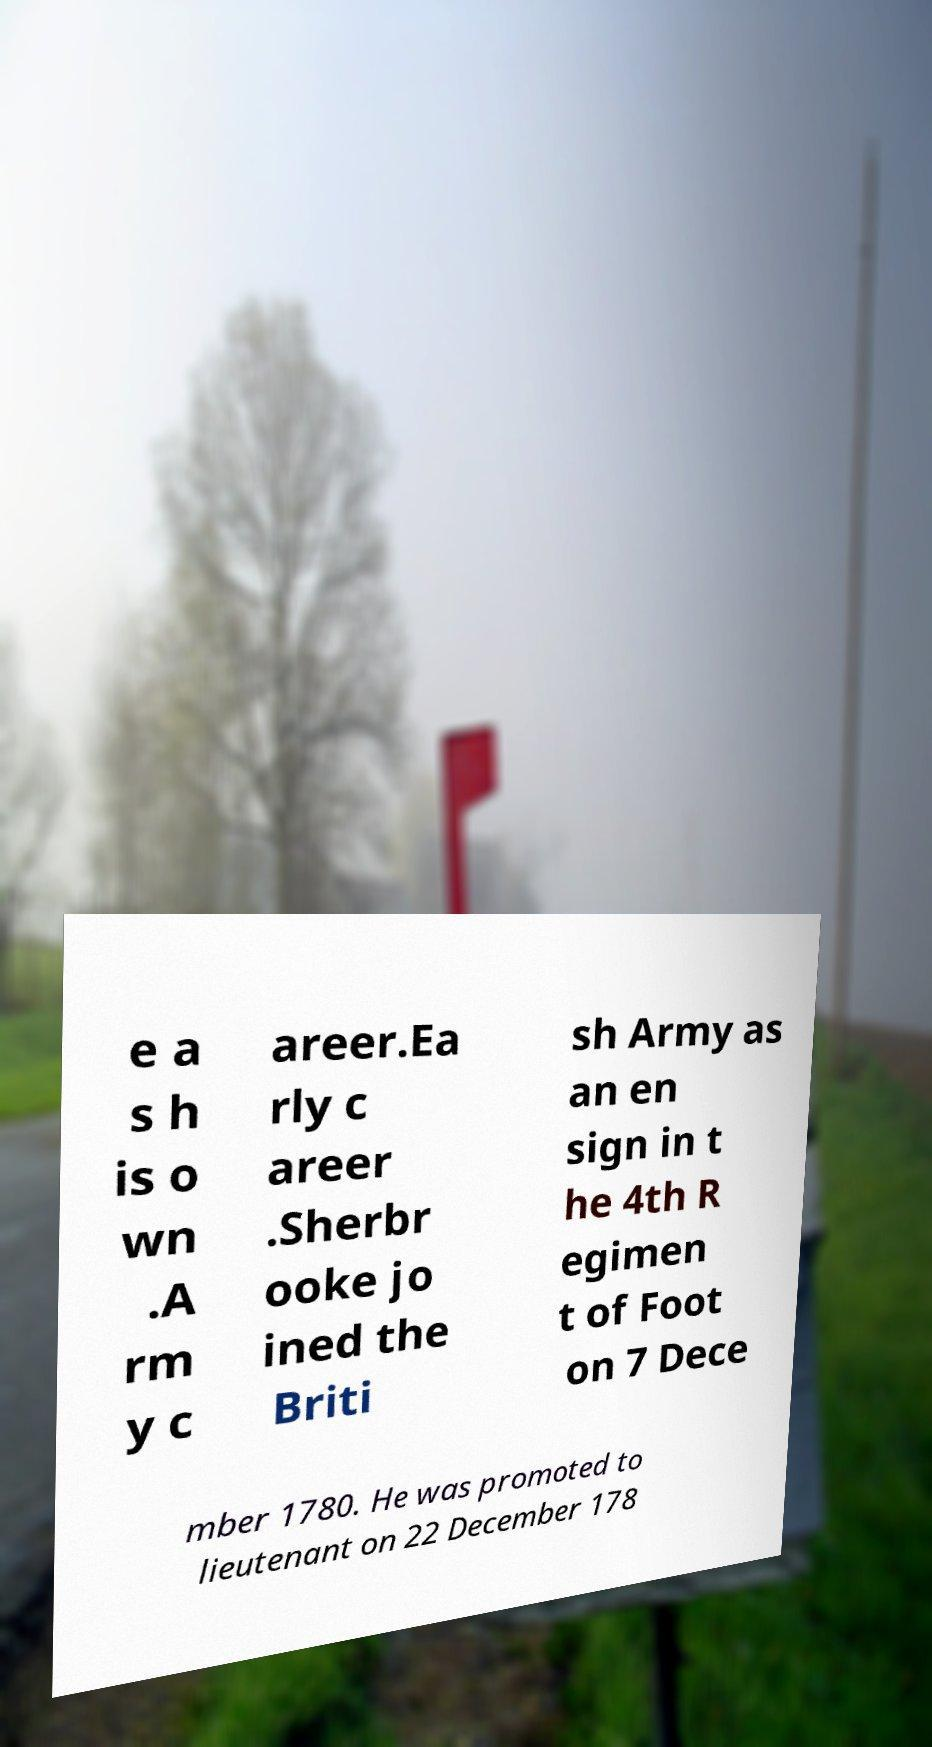Please read and relay the text visible in this image. What does it say? e a s h is o wn .A rm y c areer.Ea rly c areer .Sherbr ooke jo ined the Briti sh Army as an en sign in t he 4th R egimen t of Foot on 7 Dece mber 1780. He was promoted to lieutenant on 22 December 178 